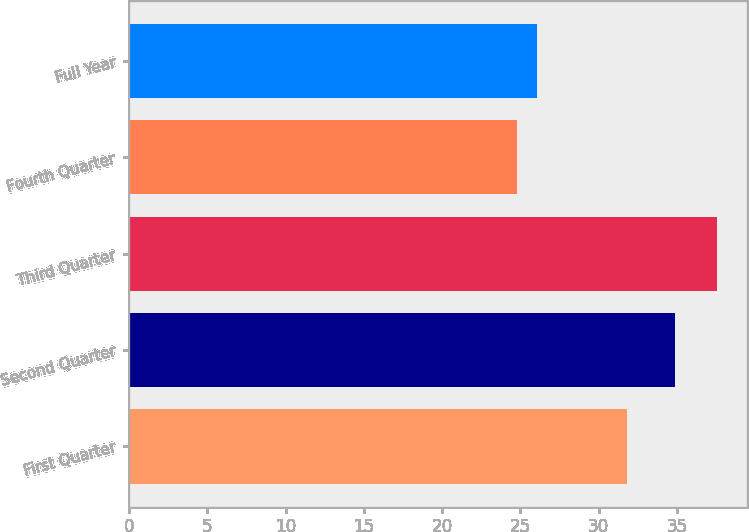<chart> <loc_0><loc_0><loc_500><loc_500><bar_chart><fcel>First Quarter<fcel>Second Quarter<fcel>Third Quarter<fcel>Fourth Quarter<fcel>Full Year<nl><fcel>31.81<fcel>34.9<fcel>37.59<fcel>24.8<fcel>26.08<nl></chart> 